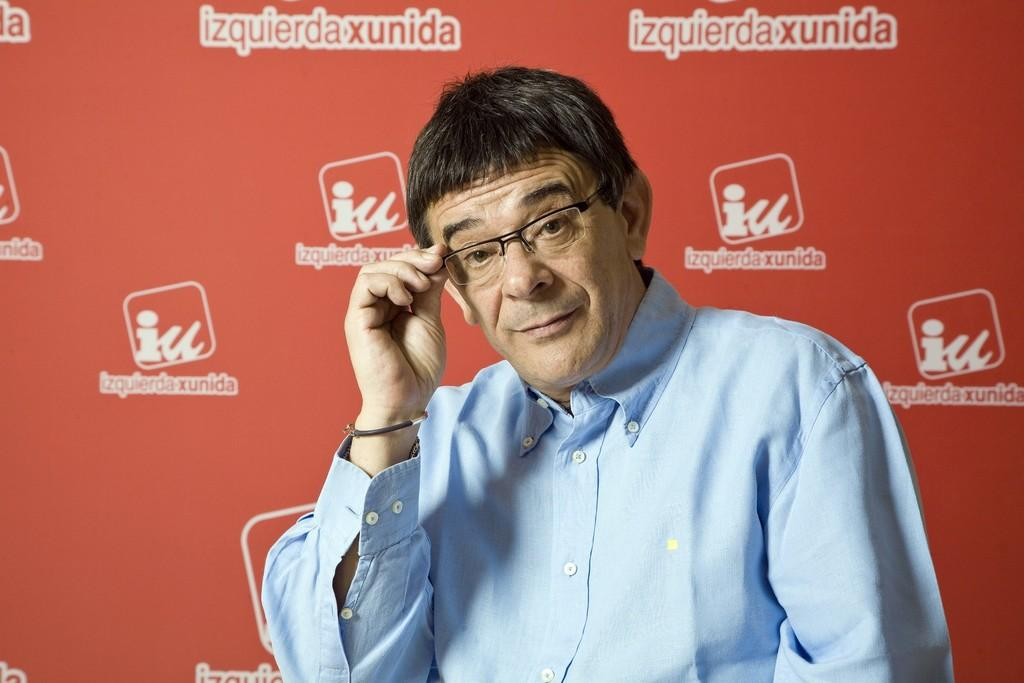What is present in the image? There is a man in the image. Can you describe the man's appearance? The man is wearing glasses. What can be seen in the background of the image? There is a board in the background of the image. What type of potato is the man holding in the image? There is no potato present in the image. What is the man's rank in the army in the image? There is no indication of the man being in the army or holding any rank in the image. 